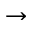Convert formula to latex. <formula><loc_0><loc_0><loc_500><loc_500>\rightarrow</formula> 